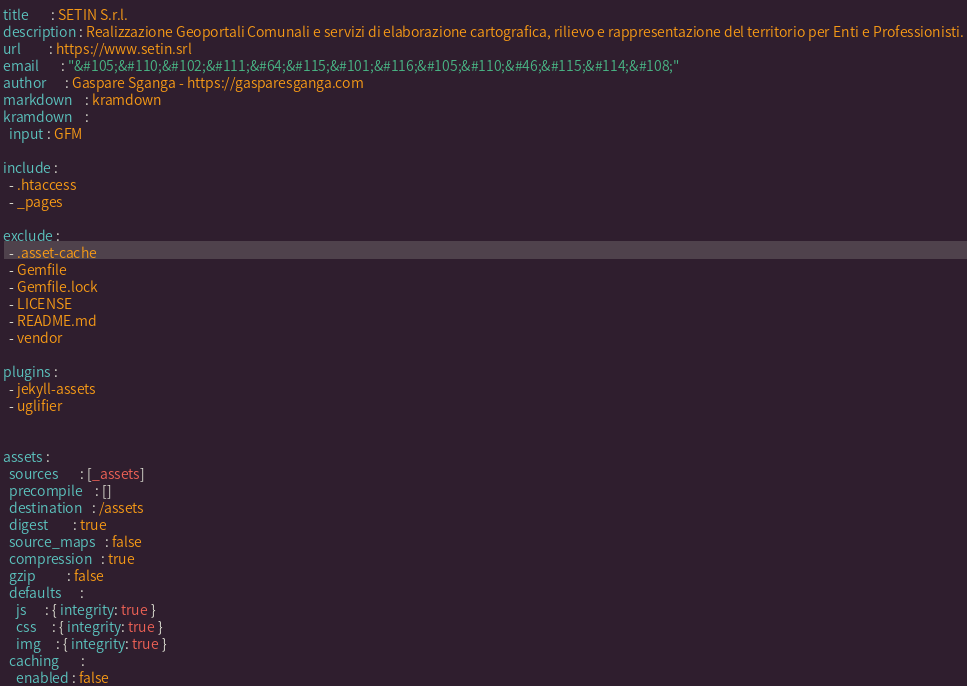<code> <loc_0><loc_0><loc_500><loc_500><_YAML_>title       : SETIN S.r.l.
description : Realizzazione Geoportali Comunali e servizi di elaborazione cartografica, rilievo e rappresentazione del territorio per Enti e Professionisti.
url         : https://www.setin.srl
email       : "&#105;&#110;&#102;&#111;&#64;&#115;&#101;&#116;&#105;&#110;&#46;&#115;&#114;&#108;"
author      : Gaspare Sganga - https://gasparesganga.com
markdown    : kramdown
kramdown    :
  input : GFM

include : 
  - .htaccess
  - _pages

exclude :
  - .asset-cache
  - Gemfile
  - Gemfile.lock
  - LICENSE
  - README.md
  - vendor

plugins :
  - jekyll-assets
  - uglifier


assets : 
  sources       : [_assets]
  precompile    : []
  destination   : /assets
  digest        : true
  source_maps   : false
  compression   : true
  gzip          : false
  defaults      :
    js      : { integrity: true }
    css     : { integrity: true }
    img     : { integrity: true }
  caching       :
    enabled : false</code> 